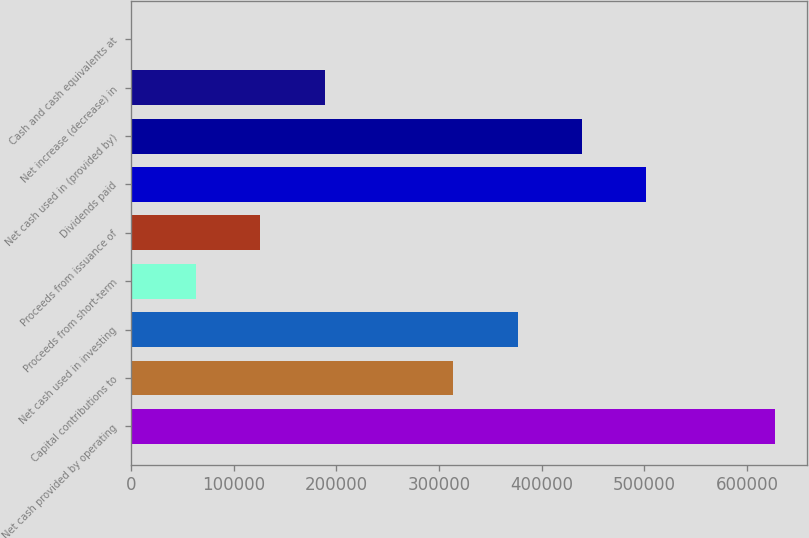Convert chart. <chart><loc_0><loc_0><loc_500><loc_500><bar_chart><fcel>Net cash provided by operating<fcel>Capital contributions to<fcel>Net cash used in investing<fcel>Proceeds from short-term<fcel>Proceeds from issuance of<fcel>Dividends paid<fcel>Net cash used in (provided by)<fcel>Net increase (decrease) in<fcel>Cash and cash equivalents at<nl><fcel>627013<fcel>313880<fcel>376507<fcel>63374.5<fcel>126001<fcel>501760<fcel>439134<fcel>188628<fcel>748<nl></chart> 